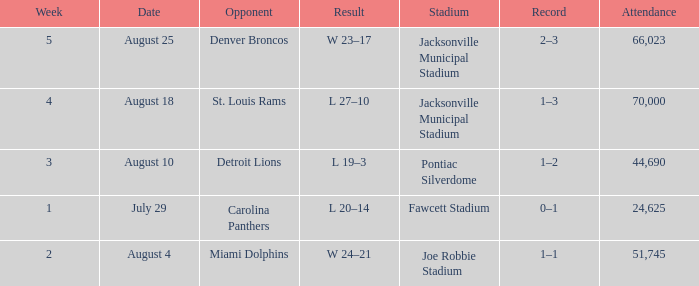WHEN has a Opponent of miami dolphins? August 4. 